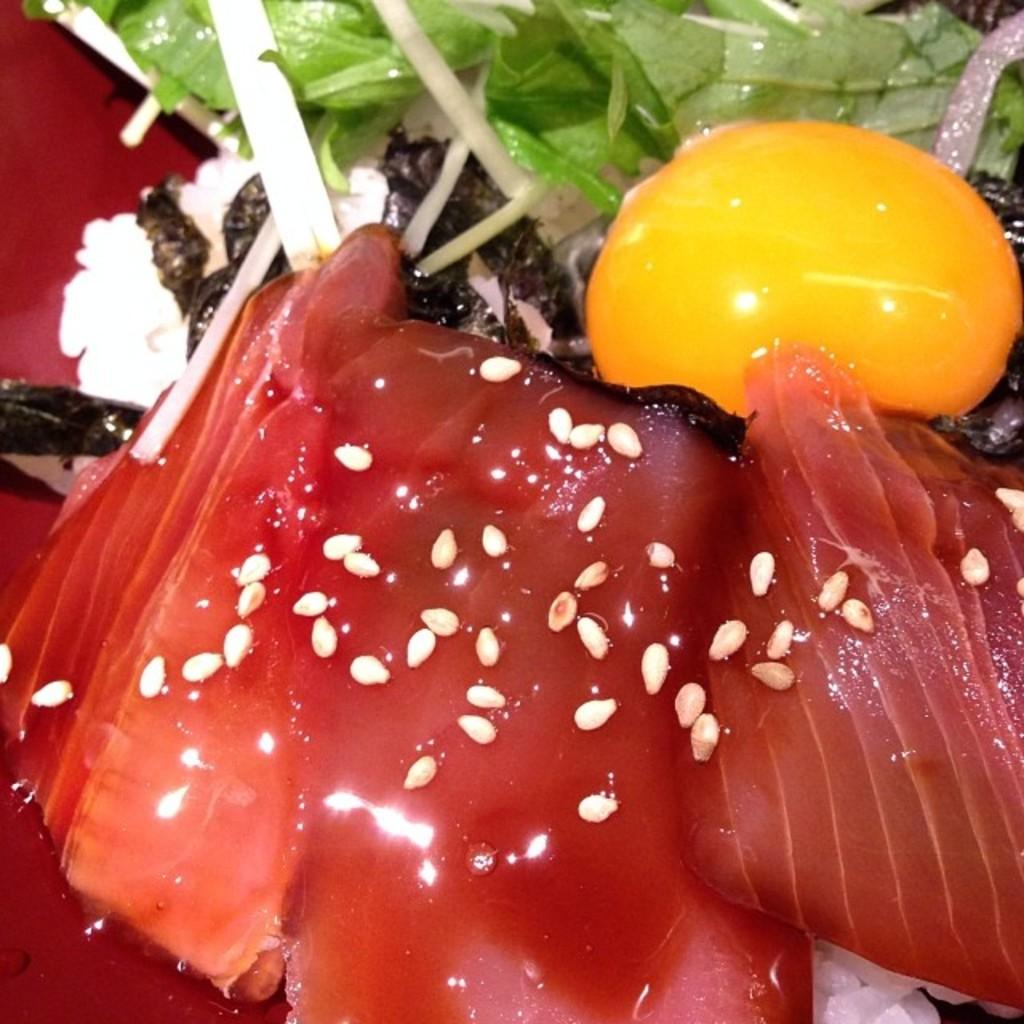What type of food can be seen in the image? There is meat in the image. What accompanies the meat in the image? There is sauce in the image. What topping is visible on the food? Sesame seeds are visible in the image. What type of vegetation is present in the image? There are green leaves in the image. What other food items can be seen in the image? There are other unspecified food items in the image. What hobbies are being practiced in the image? There is no indication of any hobbies being practiced in the image; it primarily features food items. 